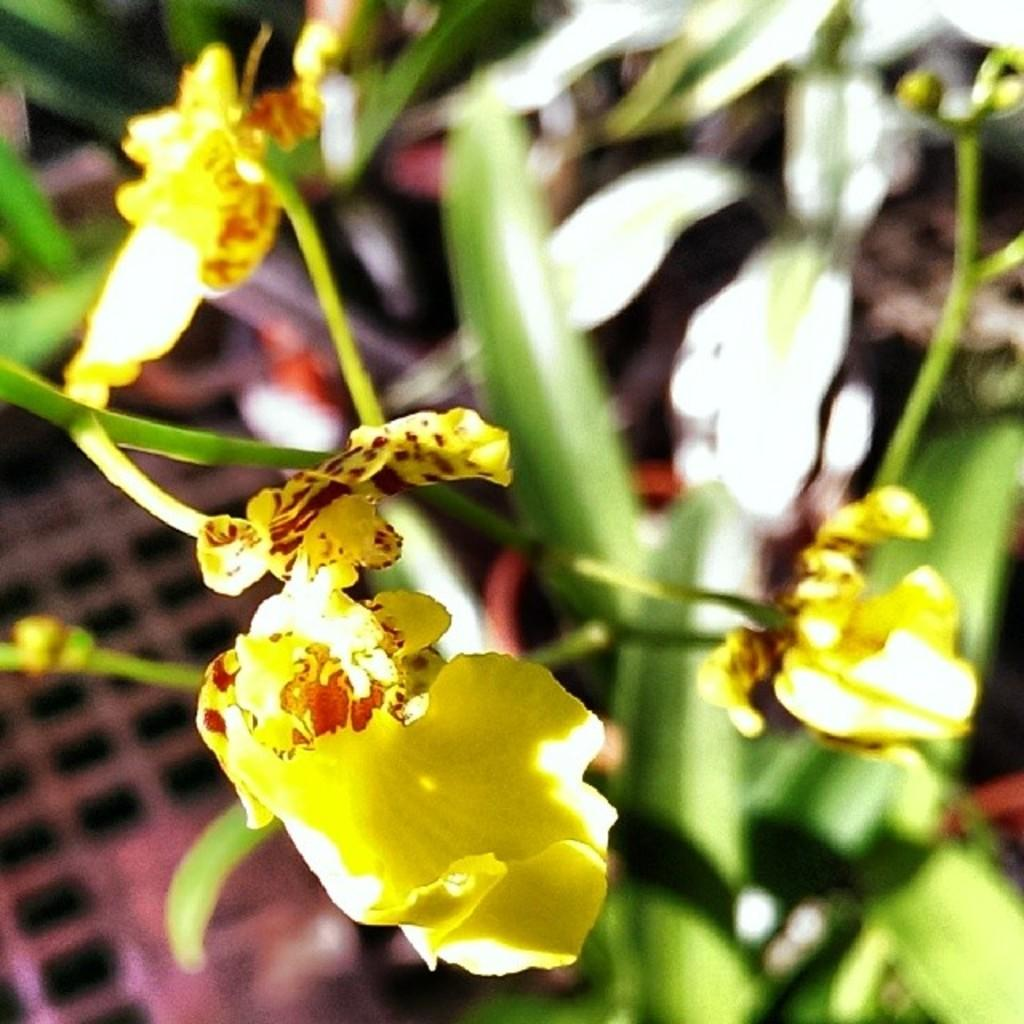What type of plants can be seen in the image? There are flower plants in the image. What color are the flowers on the plants? The flowers are yellow in color. Can you describe the background of the image? The background of the image is blurred. What type of business is being conducted in the image? There is no indication of any business activity in the image; it features flower plants with yellow flowers and a blurred background. What type of vest is visible on the plants in the image? There are no vests present in the image; it features flower plants with yellow flowers and a blurred background. 